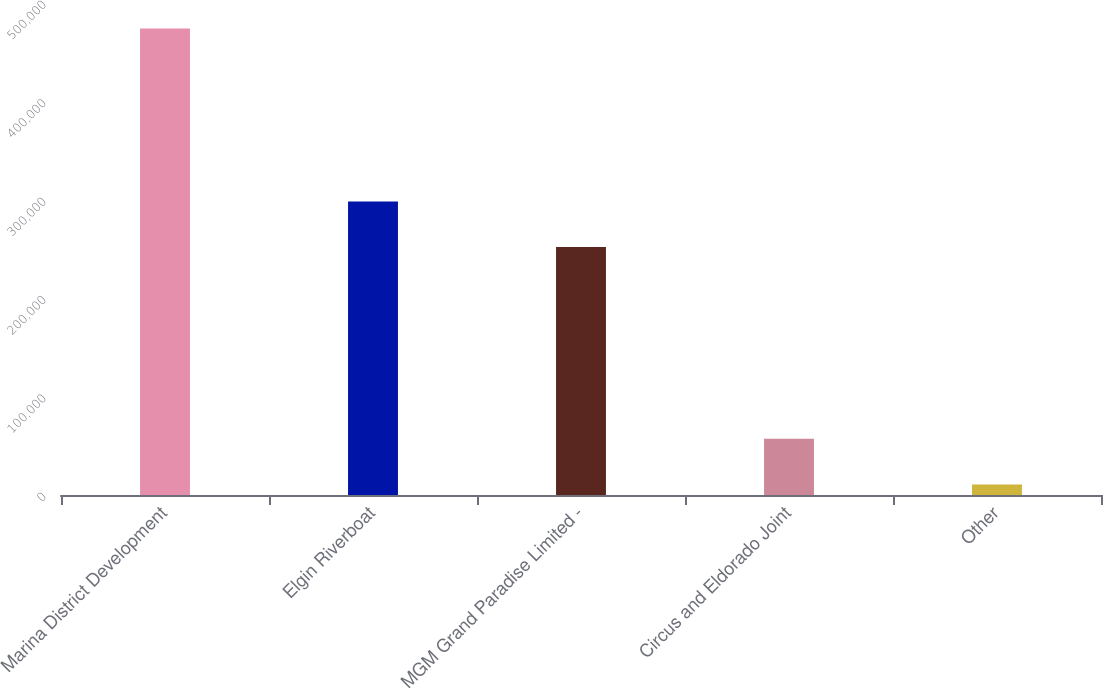Convert chart to OTSL. <chart><loc_0><loc_0><loc_500><loc_500><bar_chart><fcel>Marina District Development<fcel>Elgin Riverboat<fcel>MGM Grand Paradise Limited -<fcel>Circus and Eldorado Joint<fcel>Other<nl><fcel>474171<fcel>298398<fcel>252060<fcel>57126.3<fcel>10788<nl></chart> 